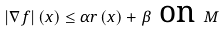<formula> <loc_0><loc_0><loc_500><loc_500>\ \left | \nabla f \right | \left ( x \right ) \leq \alpha r \left ( x \right ) + \beta \text { on } M</formula> 